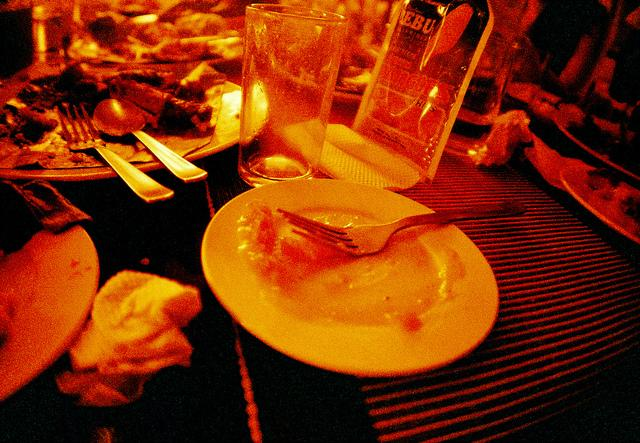Why would someone sit at this table?

Choices:
A) to eat
B) to work
C) to paint
D) to sew to eat 